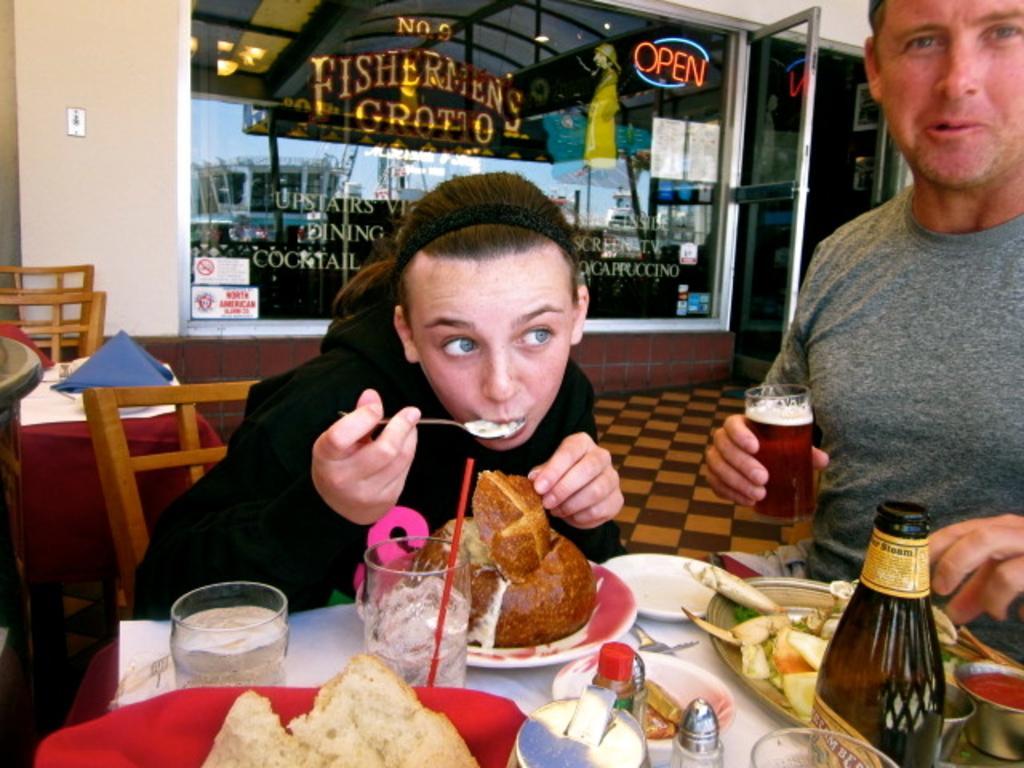In one or two sentences, can you explain what this image depicts? This picture is of inside. On the right there is a Man sitting and holding a glass of drink. In the center there is a Woman sitting on the chair and eating. In the foreground there is a table on the top of which there is a glass of water, a bottle, plates and food items are placed. In the left corner there is a table and a chair. In the background there is a wall, a window and a door, through the window we can see the sky and a building. 